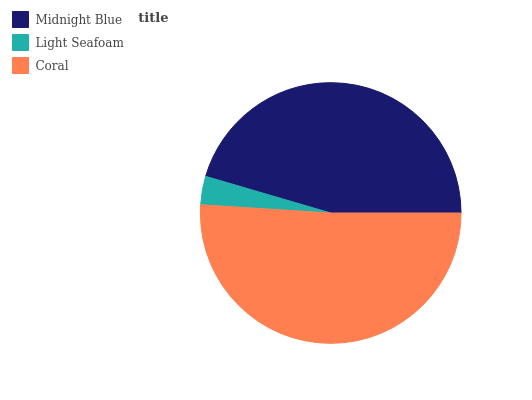Is Light Seafoam the minimum?
Answer yes or no. Yes. Is Coral the maximum?
Answer yes or no. Yes. Is Coral the minimum?
Answer yes or no. No. Is Light Seafoam the maximum?
Answer yes or no. No. Is Coral greater than Light Seafoam?
Answer yes or no. Yes. Is Light Seafoam less than Coral?
Answer yes or no. Yes. Is Light Seafoam greater than Coral?
Answer yes or no. No. Is Coral less than Light Seafoam?
Answer yes or no. No. Is Midnight Blue the high median?
Answer yes or no. Yes. Is Midnight Blue the low median?
Answer yes or no. Yes. Is Light Seafoam the high median?
Answer yes or no. No. Is Light Seafoam the low median?
Answer yes or no. No. 